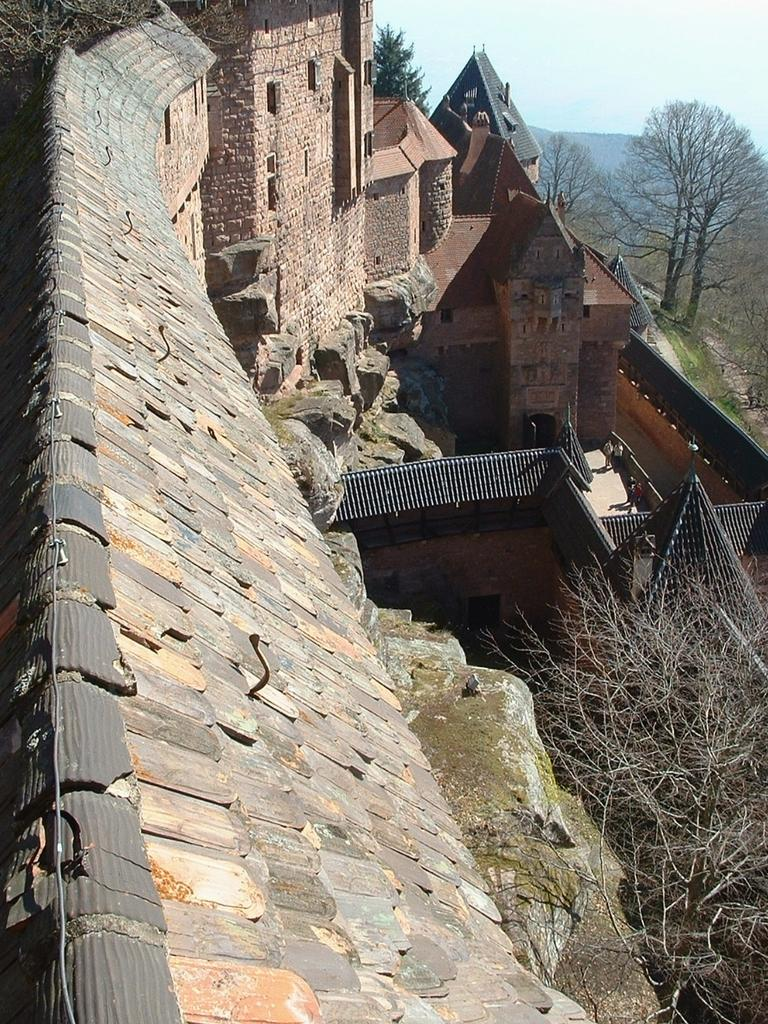What type of structure can be seen in the image? There is a castle in the image. What natural elements are present in the image? There are trees and hills in the image. What part of the castle is visible in the image? The roof of the castle is visible in the image. What is visible in the background of the image? The sky is visible in the image. What type of collar can be seen on the dress in the image? There is no dress or collar present in the image. How does the castle control the surrounding environment in the image? Castles do not have the ability to control the environment; they are inanimate structures. 